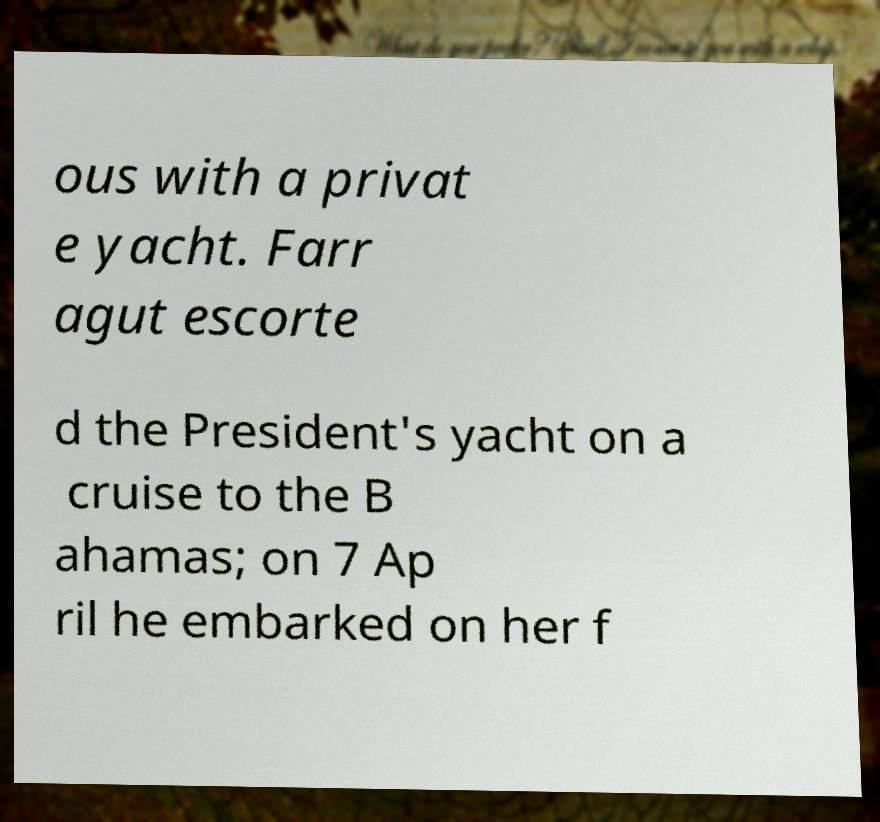Please read and relay the text visible in this image. What does it say? ous with a privat e yacht. Farr agut escorte d the President's yacht on a cruise to the B ahamas; on 7 Ap ril he embarked on her f 